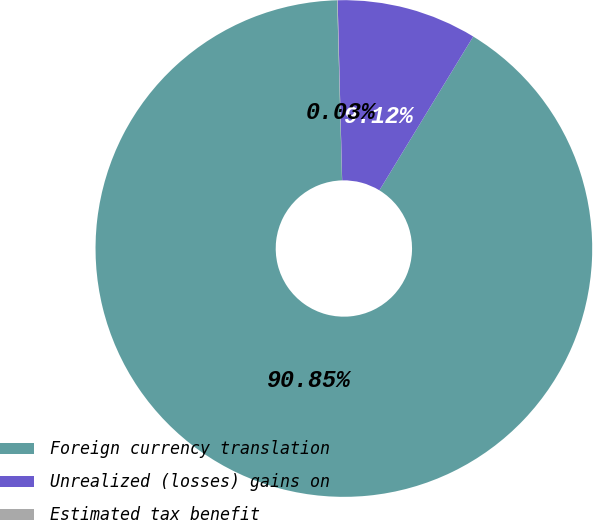Convert chart. <chart><loc_0><loc_0><loc_500><loc_500><pie_chart><fcel>Foreign currency translation<fcel>Unrealized (losses) gains on<fcel>Estimated tax benefit<nl><fcel>90.85%<fcel>9.12%<fcel>0.03%<nl></chart> 